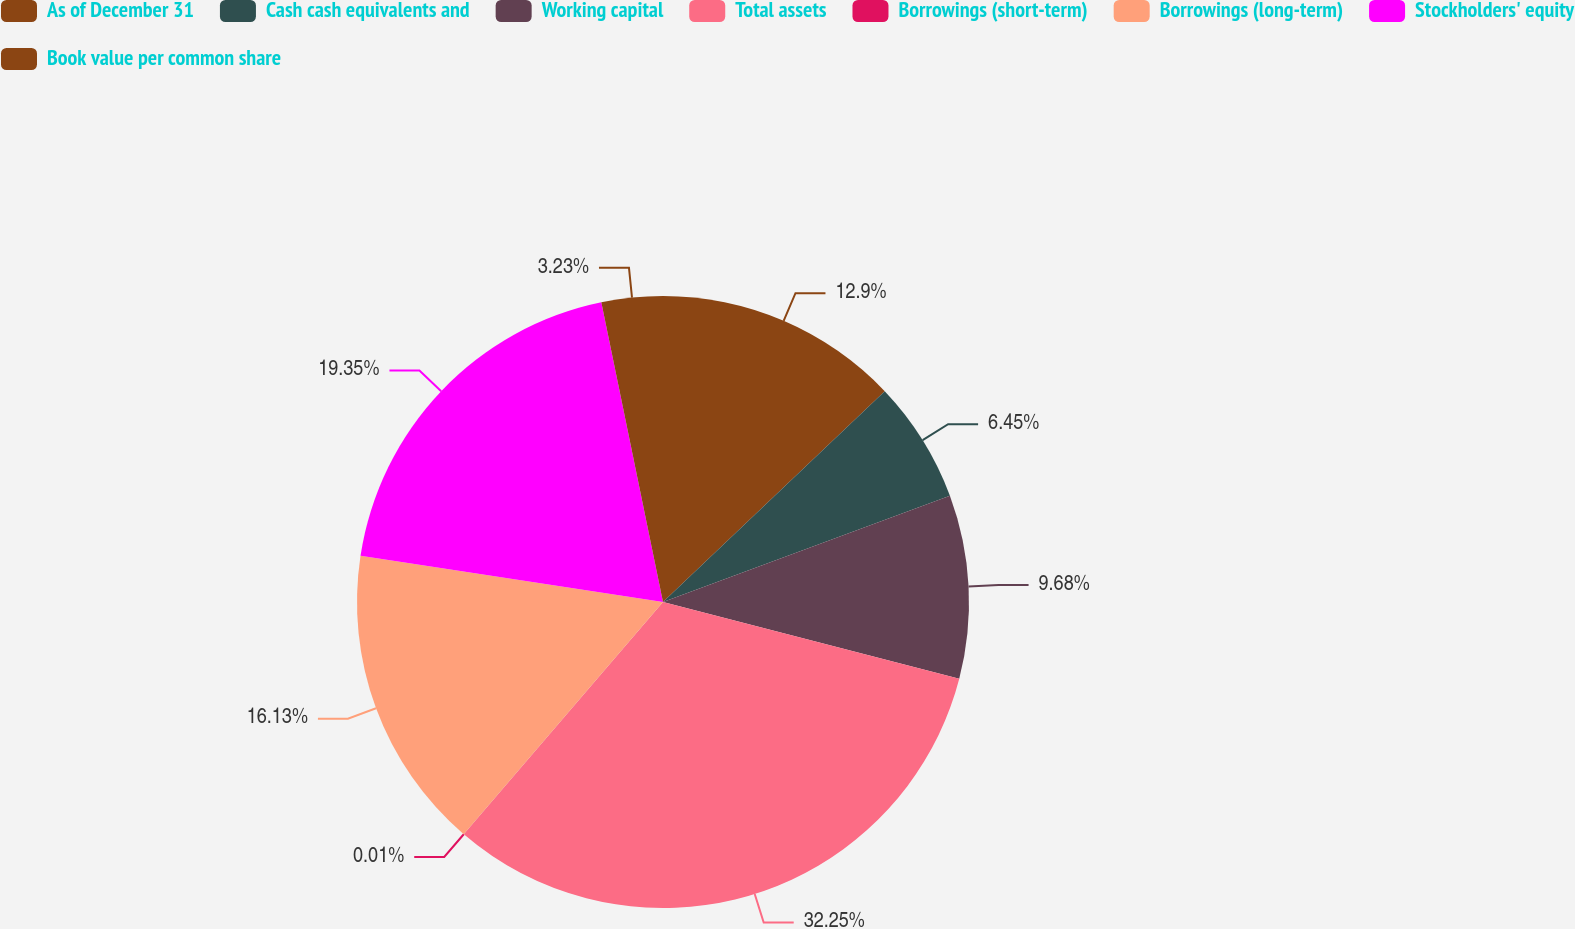Convert chart to OTSL. <chart><loc_0><loc_0><loc_500><loc_500><pie_chart><fcel>As of December 31<fcel>Cash cash equivalents and<fcel>Working capital<fcel>Total assets<fcel>Borrowings (short-term)<fcel>Borrowings (long-term)<fcel>Stockholders' equity<fcel>Book value per common share<nl><fcel>12.9%<fcel>6.45%<fcel>9.68%<fcel>32.25%<fcel>0.01%<fcel>16.13%<fcel>19.35%<fcel>3.23%<nl></chart> 